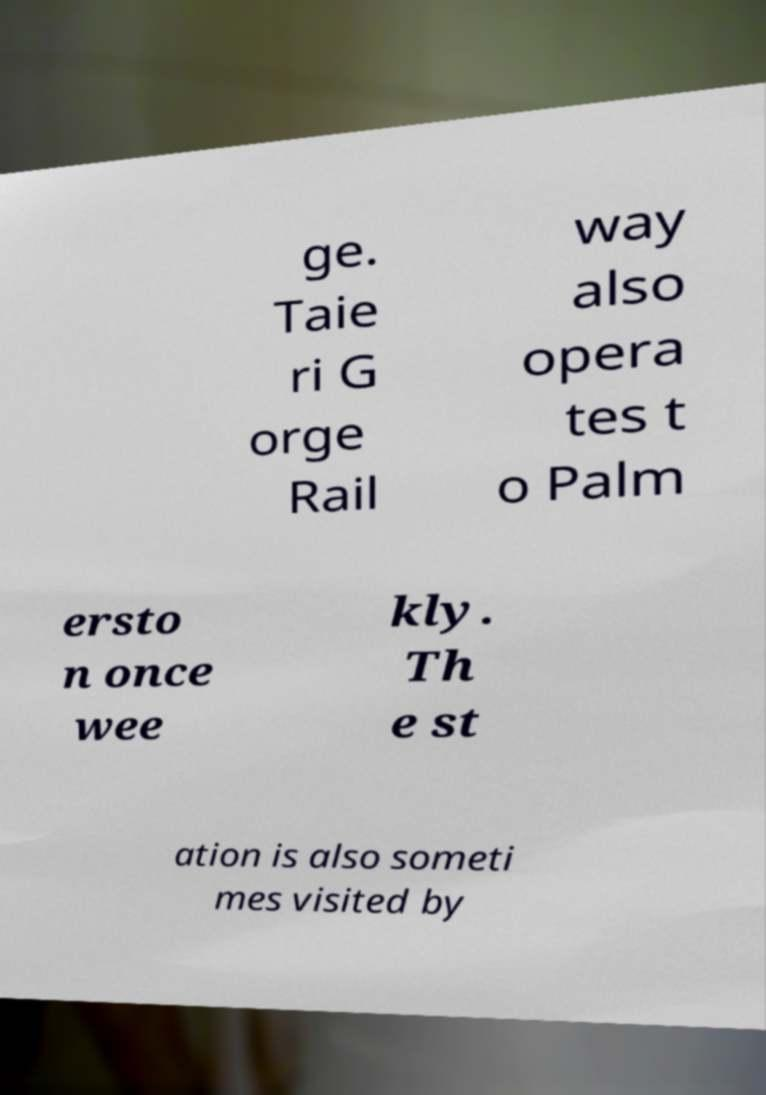I need the written content from this picture converted into text. Can you do that? ge. Taie ri G orge Rail way also opera tes t o Palm ersto n once wee kly. Th e st ation is also someti mes visited by 